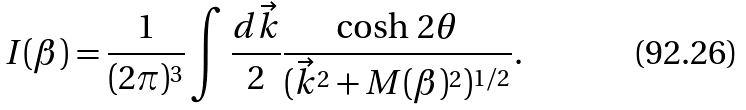Convert formula to latex. <formula><loc_0><loc_0><loc_500><loc_500>I ( \beta ) = \frac { 1 } { ( 2 \pi ) ^ { 3 } } \int \frac { d \vec { k } } { 2 } \frac { \cosh \, 2 \theta } { ( \vec { k } ^ { 2 } + M ( \beta ) ^ { 2 } ) ^ { 1 / 2 } } .</formula> 